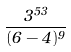<formula> <loc_0><loc_0><loc_500><loc_500>\frac { 3 ^ { 5 3 } } { ( 6 - 4 ) ^ { 9 } }</formula> 